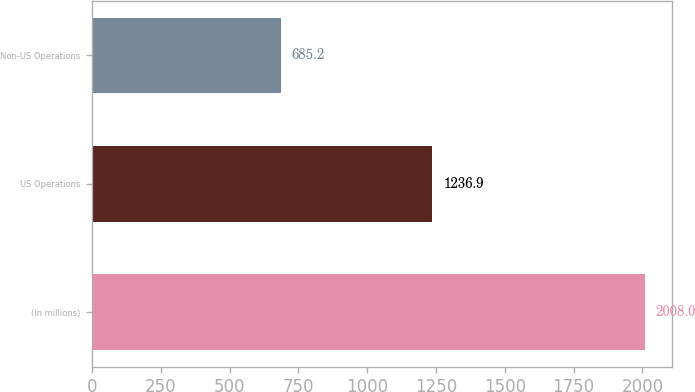Convert chart. <chart><loc_0><loc_0><loc_500><loc_500><bar_chart><fcel>(in millions)<fcel>US Operations<fcel>Non-US Operations<nl><fcel>2008<fcel>1236.9<fcel>685.2<nl></chart> 